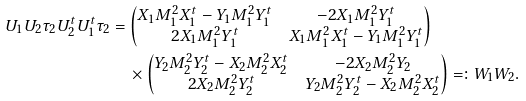Convert formula to latex. <formula><loc_0><loc_0><loc_500><loc_500>U _ { 1 } U _ { 2 } \tau _ { 2 } U _ { 2 } ^ { t } U _ { 1 } ^ { t } \tau _ { 2 } & = \begin{pmatrix} X _ { 1 } M _ { 1 } ^ { 2 } X _ { 1 } ^ { t } - Y _ { 1 } M _ { 1 } ^ { 2 } Y _ { 1 } ^ { t } & - 2 X _ { 1 } M _ { 1 } ^ { 2 } Y _ { 1 } ^ { t } \\ 2 X _ { 1 } M _ { 1 } ^ { 2 } Y _ { 1 } ^ { t } & X _ { 1 } M _ { 1 } ^ { 2 } X _ { 1 } ^ { t } - Y _ { 1 } M _ { 1 } ^ { 2 } Y _ { 1 } ^ { t } \end{pmatrix} \\ & \quad \times \begin{pmatrix} Y _ { 2 } M _ { 2 } ^ { 2 } Y _ { 2 } ^ { t } - X _ { 2 } M _ { 2 } ^ { 2 } X _ { 2 } ^ { t } & - 2 X _ { 2 } M _ { 2 } ^ { 2 } Y _ { 2 } \\ 2 X _ { 2 } M _ { 2 } ^ { 2 } Y _ { 2 } ^ { t } & Y _ { 2 } M _ { 2 } ^ { 2 } Y _ { 2 } ^ { t } - X _ { 2 } M _ { 2 } ^ { 2 } X _ { 2 } ^ { t } \end{pmatrix} = \colon W _ { 1 } W _ { 2 } .</formula> 